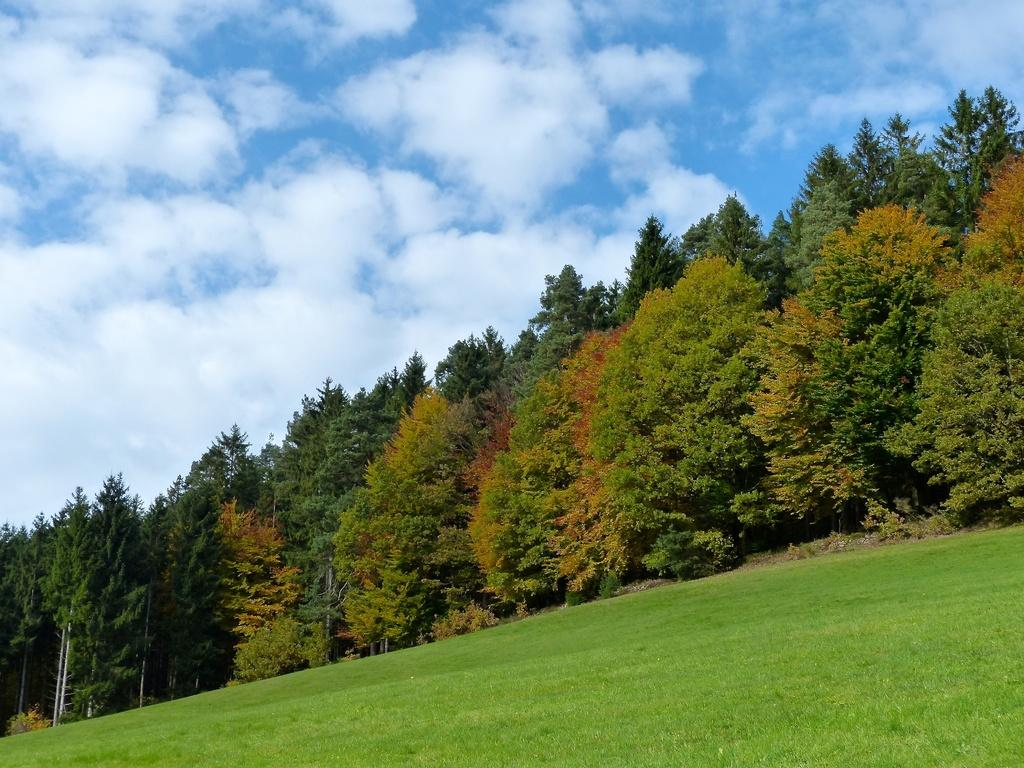What type of vegetation is present in the image? There are many trees in the image. What is the color of the grass at the bottom of the image? The grass at the bottom of the image is green. What can be seen in the sky at the top of the image? There are clouds in the sky at the top of the image. What type of noise can be heard coming from the elbow in the image? There is no elbow present in the image, so it is not possible to determine what, if any, noise might be heard. 